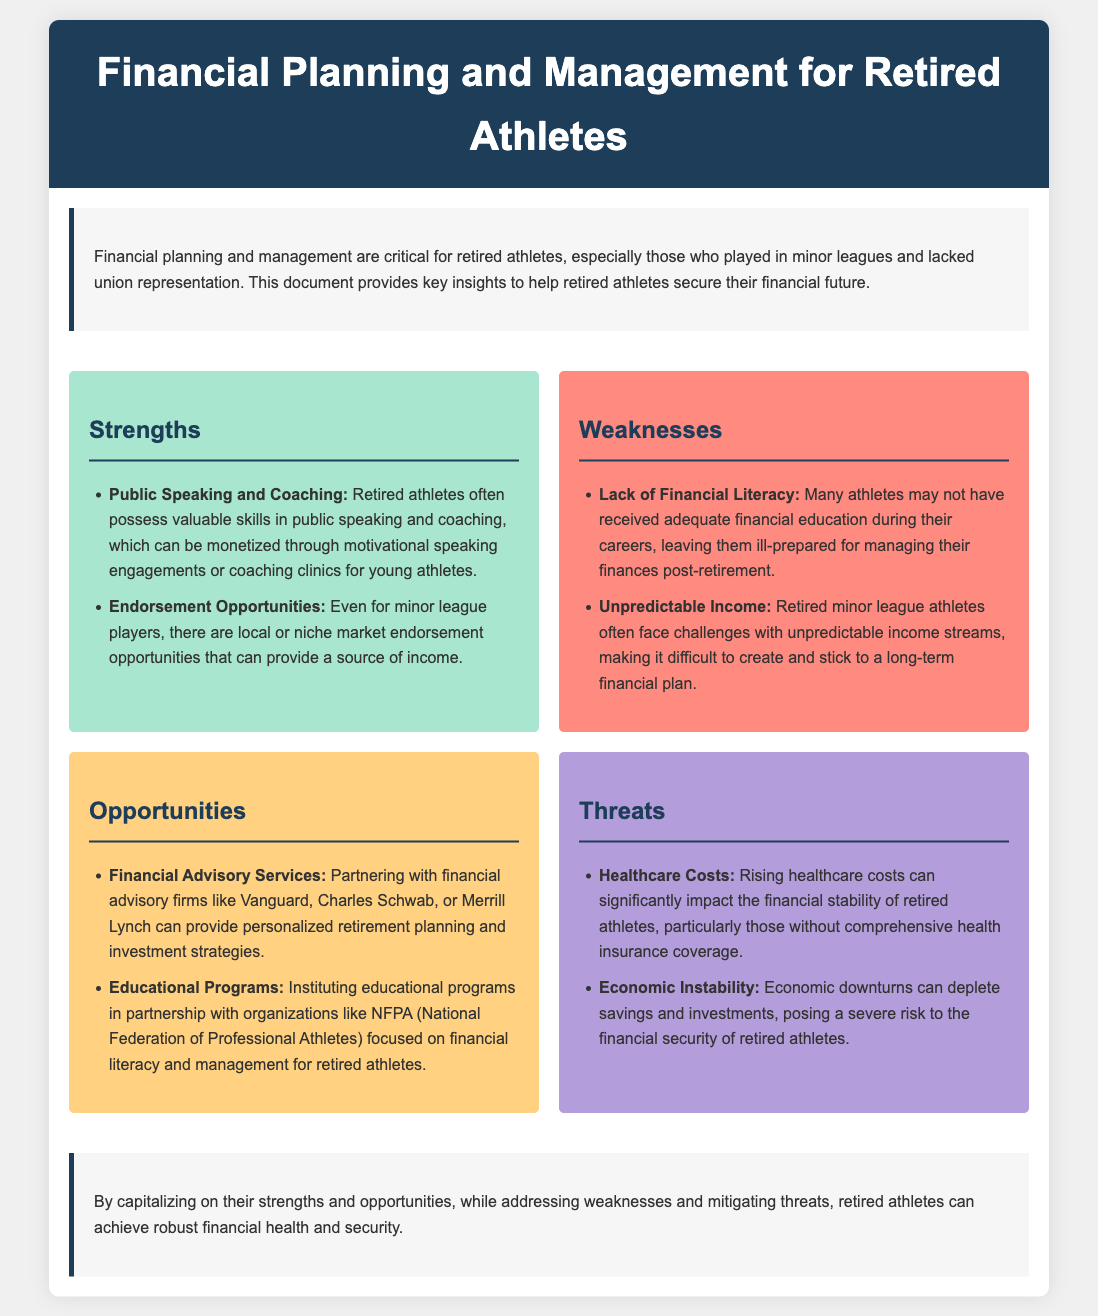What are two strengths of retired athletes? The document lists skills in public speaking and coaching, as well as endorsement opportunities as strengths.
Answer: Public Speaking and Coaching, Endorsement Opportunities What is a weakness related to financial education? The document identifies that many athletes may not have received adequate financial education during their careers.
Answer: Lack of Financial Literacy What is a threat regarding healthcare? The document notes that rising healthcare costs can significantly impact financial stability.
Answer: Healthcare Costs Which financial advisory services are suggested? The document mentions partnering with firms like Vanguard, Charles Schwab, or Merrill Lynch as options.
Answer: Vanguard, Charles Schwab, Merrill Lynch What opportunity focuses on financial literacy? The document highlights instituting educational programs in partnership with organizations like NFPA.
Answer: Educational Programs What is a key challenge mentioned for income streams? The document states that retired minor league athletes often face unpredictable income streams.
Answer: Unpredictable Income How does the document suggest addressing economic risks? It implies that retired athletes should focus on mitigating economic instability to protect their finances.
Answer: Mitigating economic instability What is emphasized as crucial for retired athletes? The document stresses the importance of financial planning and management for securing their financial future.
Answer: Financial planning and management 